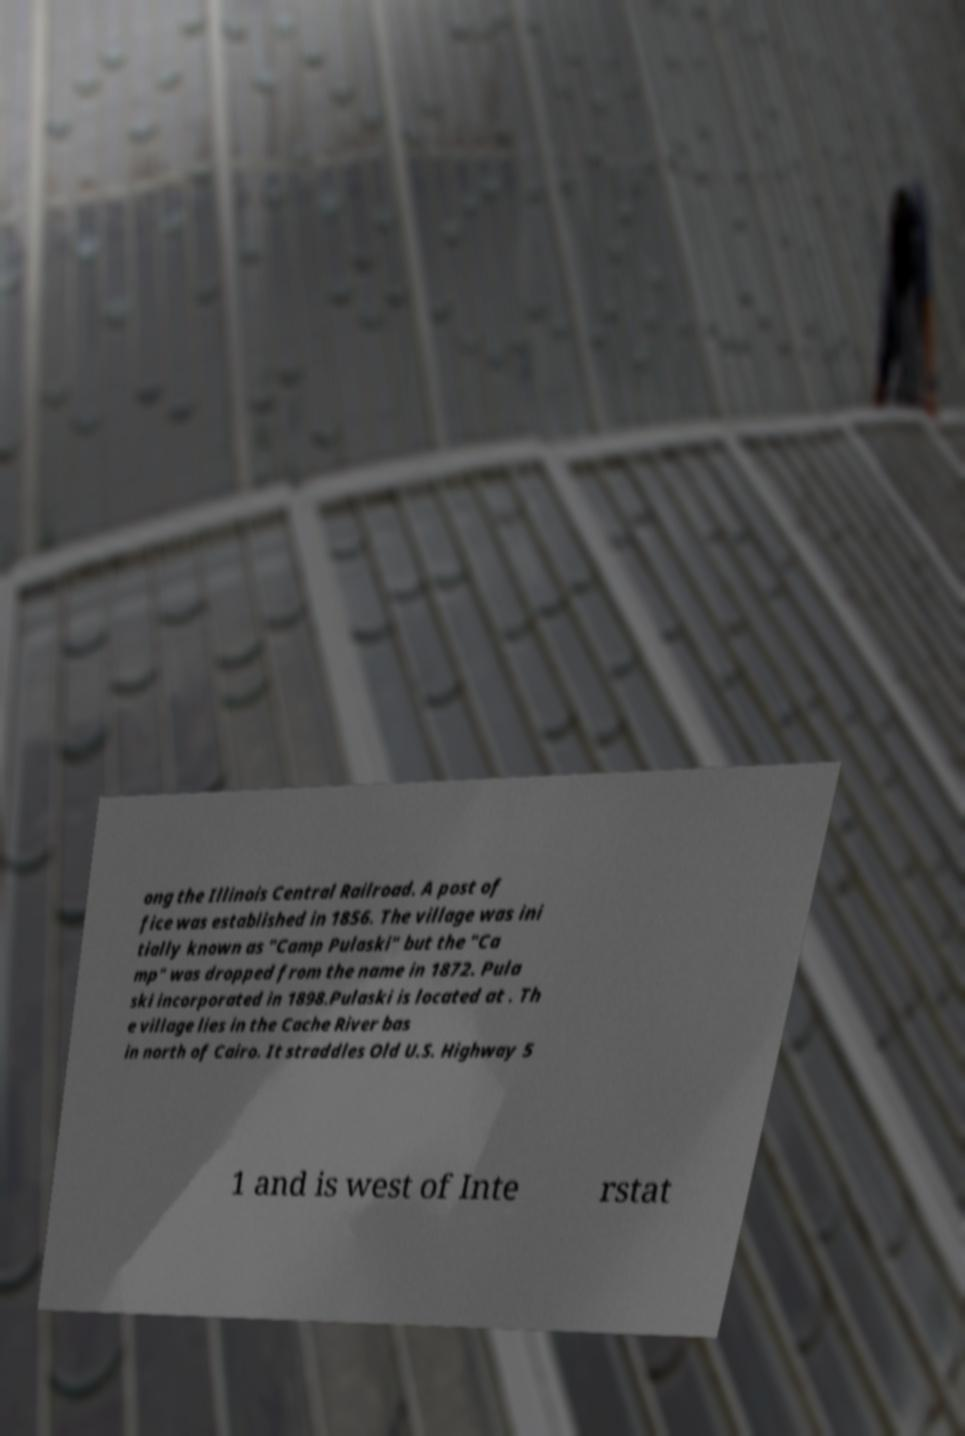There's text embedded in this image that I need extracted. Can you transcribe it verbatim? ong the Illinois Central Railroad. A post of fice was established in 1856. The village was ini tially known as "Camp Pulaski" but the "Ca mp" was dropped from the name in 1872. Pula ski incorporated in 1898.Pulaski is located at . Th e village lies in the Cache River bas in north of Cairo. It straddles Old U.S. Highway 5 1 and is west of Inte rstat 